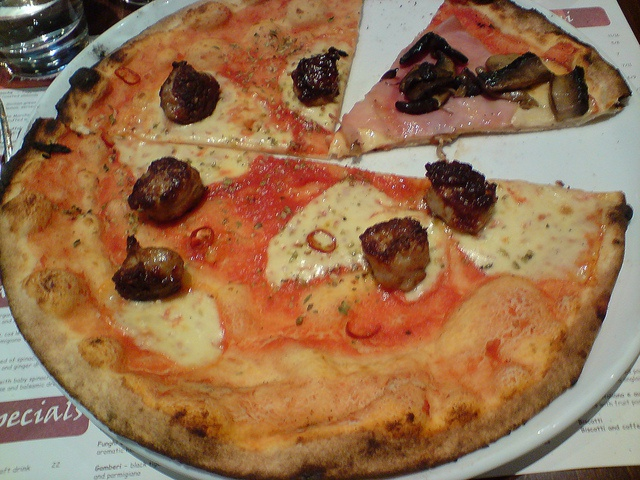Describe the objects in this image and their specific colors. I can see pizza in black, brown, and tan tones, pizza in black, brown, gray, and tan tones, pizza in black, brown, and maroon tones, and cup in black, gray, ivory, and darkgray tones in this image. 